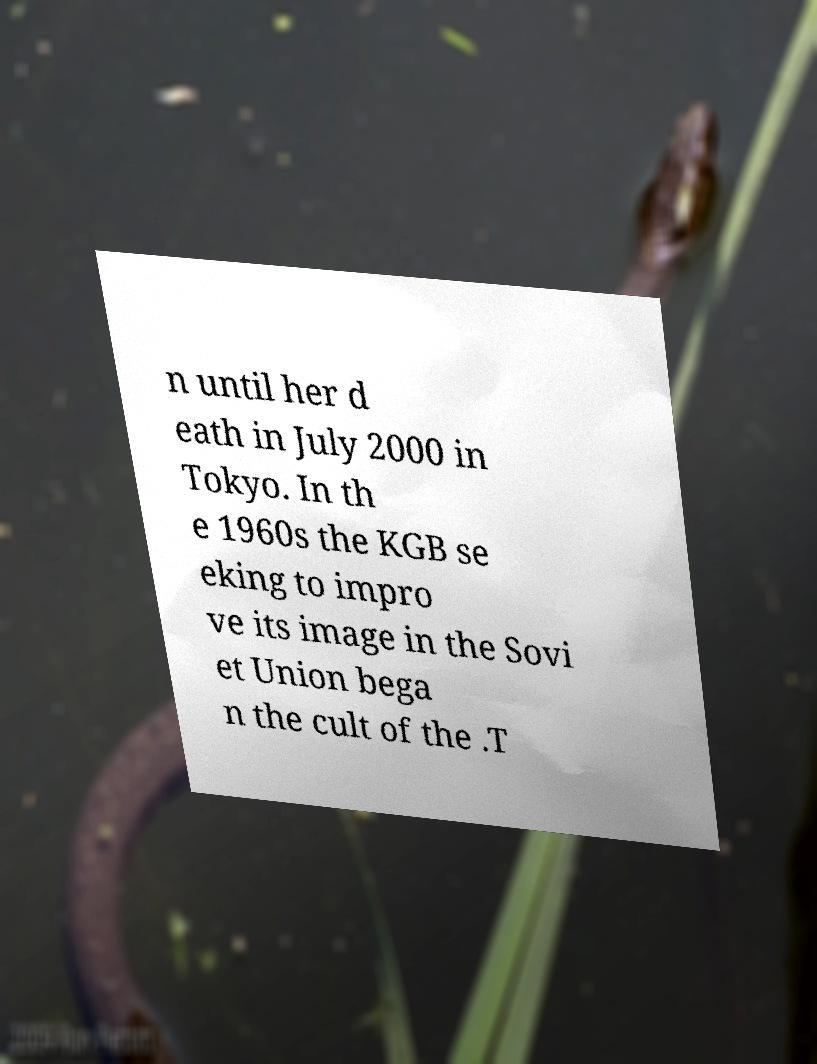Can you accurately transcribe the text from the provided image for me? n until her d eath in July 2000 in Tokyo. In th e 1960s the KGB se eking to impro ve its image in the Sovi et Union bega n the cult of the .T 